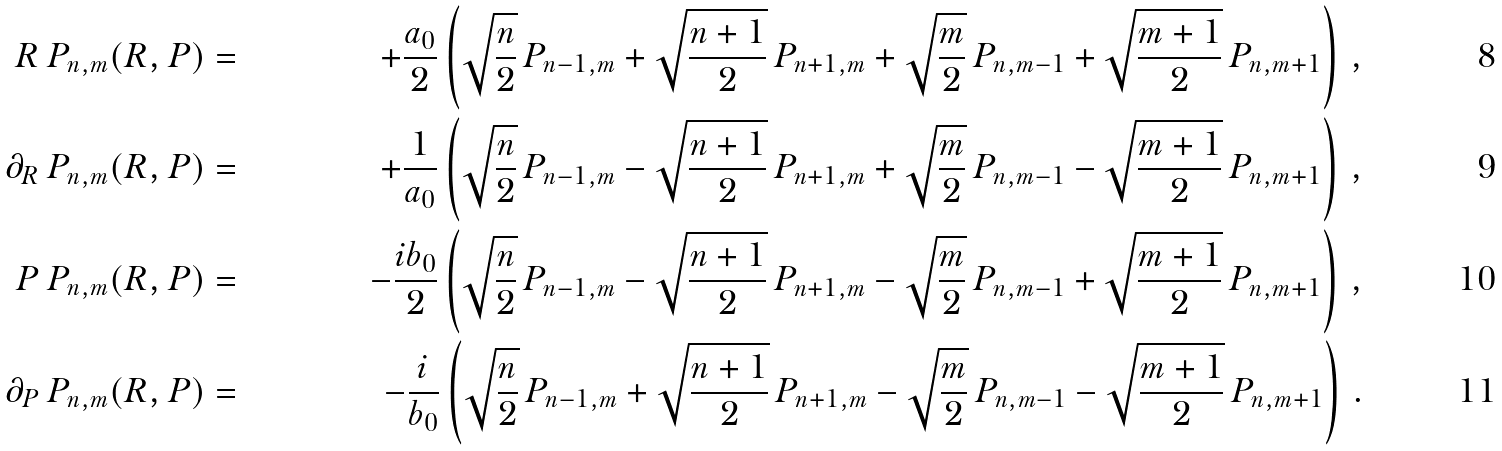Convert formula to latex. <formula><loc_0><loc_0><loc_500><loc_500>R \, P _ { n , m } ( R , P ) & = & + \frac { a _ { 0 } } { 2 } \left ( \sqrt { \frac { n } { 2 } } \, P _ { n - 1 , m } + \sqrt { \frac { n + 1 } { 2 } } \, P _ { n + 1 , m } + \sqrt { \frac { m } { 2 } } \, P _ { n , m - 1 } + \sqrt { \frac { m + 1 } { 2 } } \, P _ { n , m + 1 } \right ) \, , \\ \partial _ { R } \, P _ { n , m } ( R , P ) & = & + \frac { 1 } { a _ { 0 } } \left ( \sqrt { \frac { n } { 2 } } \, P _ { n - 1 , m } - \sqrt { \frac { n + 1 } { 2 } } \, P _ { n + 1 , m } + \sqrt { \frac { m } { 2 } } \, P _ { n , m - 1 } - \sqrt { \frac { m + 1 } { 2 } } \, P _ { n , m + 1 } \right ) \, , \\ P \, P _ { n , m } ( R , P ) & = & - \frac { i b _ { 0 } } { 2 } \left ( \sqrt { \frac { n } { 2 } } \, P _ { n - 1 , m } - \sqrt { \frac { n + 1 } { 2 } } \, P _ { n + 1 , m } - \sqrt { \frac { m } { 2 } } \, P _ { n , m - 1 } + \sqrt { \frac { m + 1 } { 2 } } \, P _ { n , m + 1 } \right ) \, , \\ \partial _ { P } \, P _ { n , m } ( R , P ) & = & - \frac { i } { b _ { 0 } } \left ( \sqrt { \frac { n } { 2 } } \, P _ { n - 1 , m } + \sqrt { \frac { n + 1 } { 2 } } \, P _ { n + 1 , m } - \sqrt { \frac { m } { 2 } } \, P _ { n , m - 1 } - \sqrt { \frac { m + 1 } { 2 } } \, P _ { n , m + 1 } \right ) \, .</formula> 